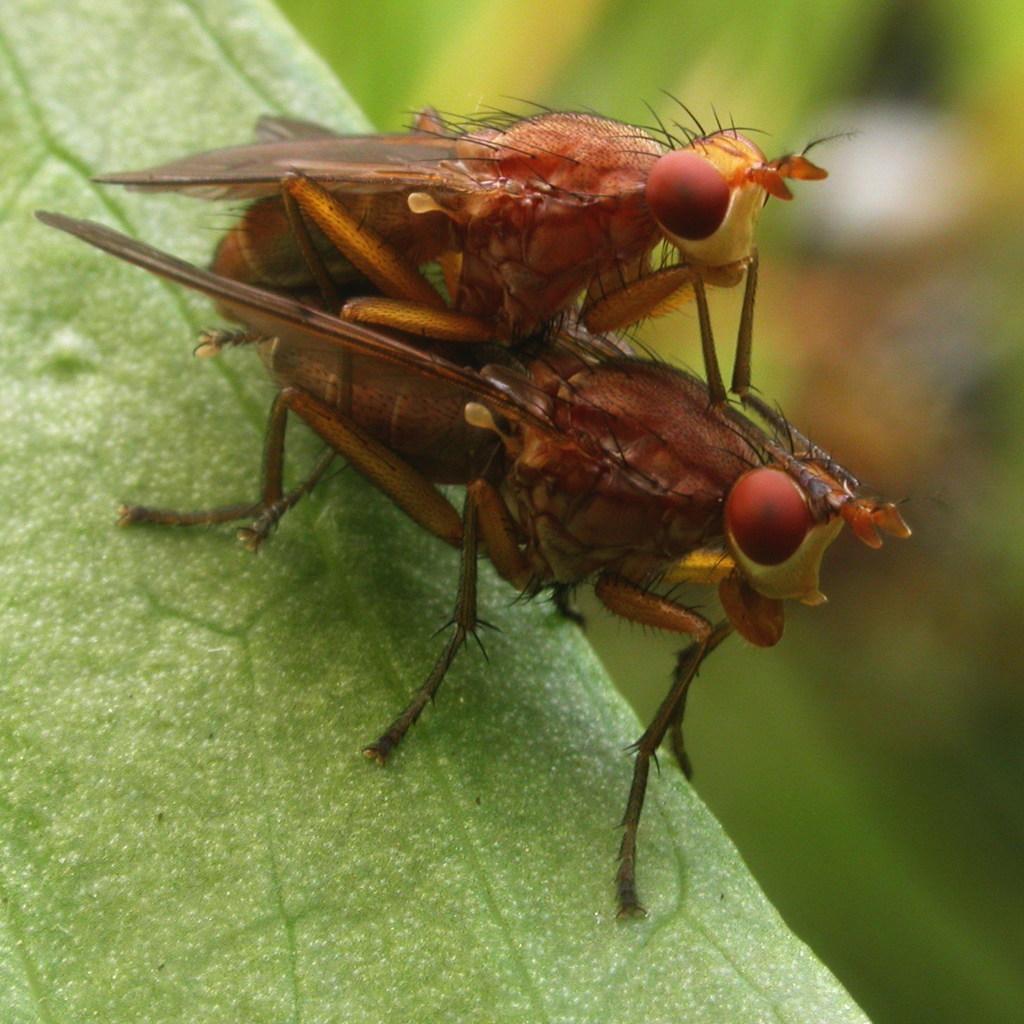Can you describe this image briefly? In this image we can see insects on the plant. 